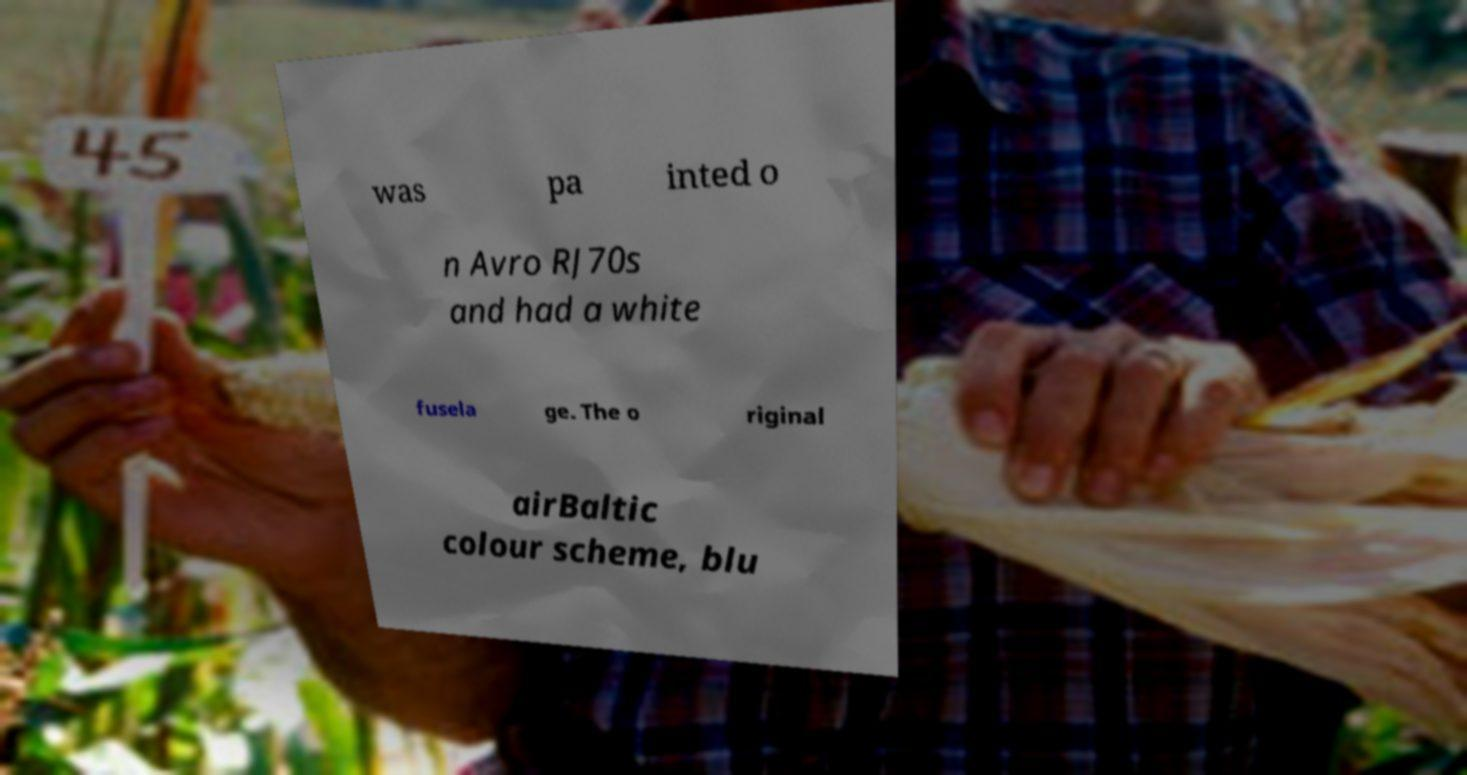Can you accurately transcribe the text from the provided image for me? was pa inted o n Avro RJ70s and had a white fusela ge. The o riginal airBaltic colour scheme, blu 